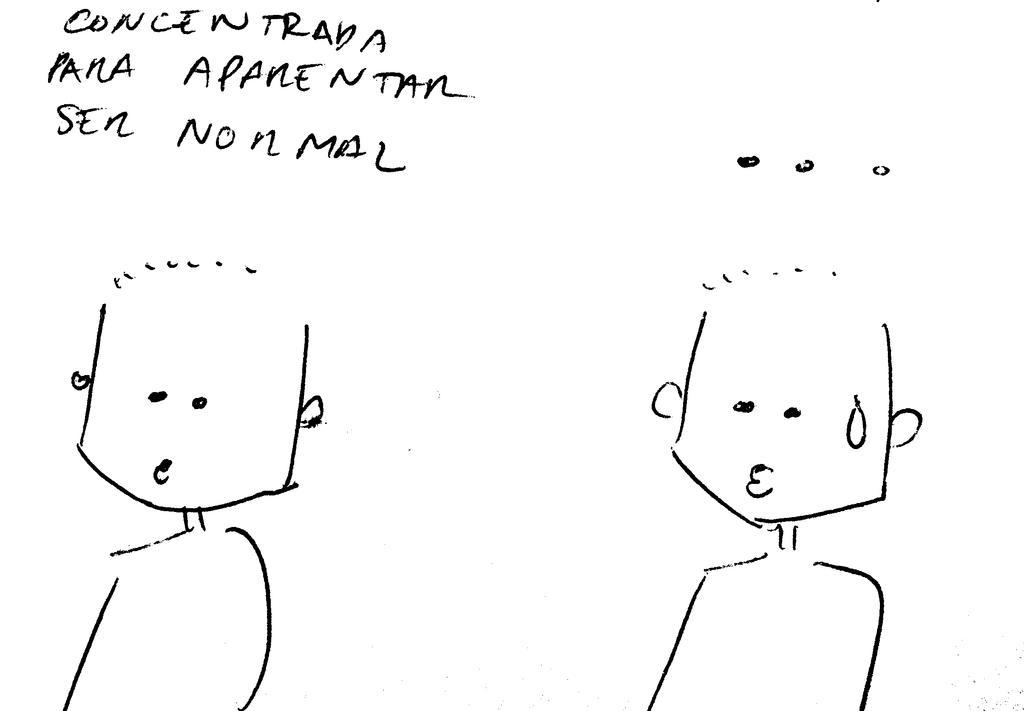Could you give a brief overview of what you see in this image? In this image, we can see a sketch of cartoons and there is some text. 